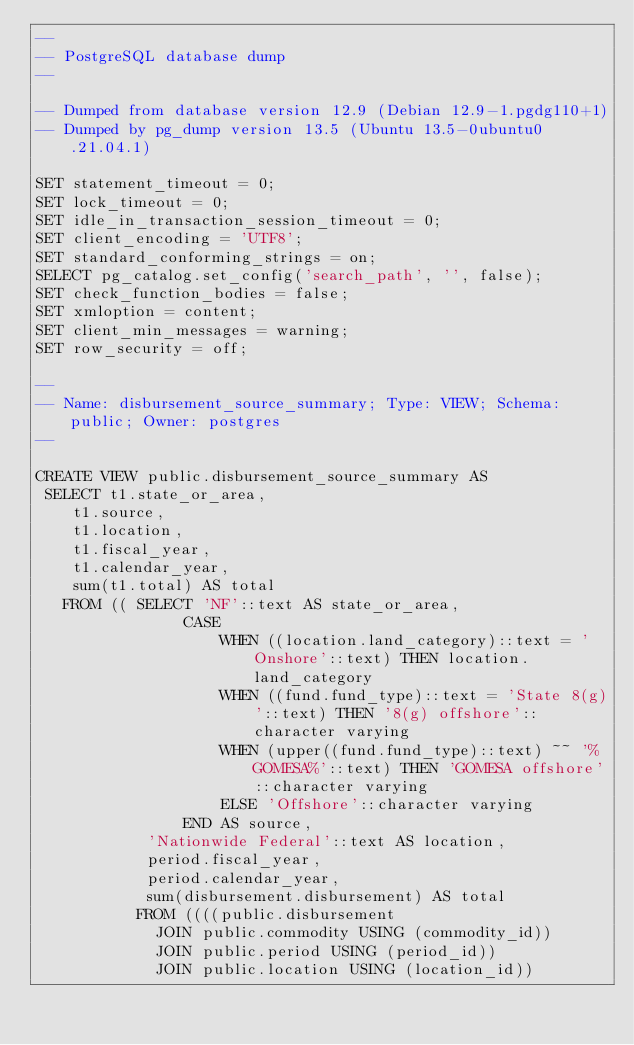Convert code to text. <code><loc_0><loc_0><loc_500><loc_500><_SQL_>--
-- PostgreSQL database dump
--

-- Dumped from database version 12.9 (Debian 12.9-1.pgdg110+1)
-- Dumped by pg_dump version 13.5 (Ubuntu 13.5-0ubuntu0.21.04.1)

SET statement_timeout = 0;
SET lock_timeout = 0;
SET idle_in_transaction_session_timeout = 0;
SET client_encoding = 'UTF8';
SET standard_conforming_strings = on;
SELECT pg_catalog.set_config('search_path', '', false);
SET check_function_bodies = false;
SET xmloption = content;
SET client_min_messages = warning;
SET row_security = off;

--
-- Name: disbursement_source_summary; Type: VIEW; Schema: public; Owner: postgres
--

CREATE VIEW public.disbursement_source_summary AS
 SELECT t1.state_or_area,
    t1.source,
    t1.location,
    t1.fiscal_year,
    t1.calendar_year,
    sum(t1.total) AS total
   FROM (( SELECT 'NF'::text AS state_or_area,
                CASE
                    WHEN ((location.land_category)::text = 'Onshore'::text) THEN location.land_category
                    WHEN ((fund.fund_type)::text = 'State 8(g)'::text) THEN '8(g) offshore'::character varying
                    WHEN (upper((fund.fund_type)::text) ~~ '%GOMESA%'::text) THEN 'GOMESA offshore'::character varying
                    ELSE 'Offshore'::character varying
                END AS source,
            'Nationwide Federal'::text AS location,
            period.fiscal_year,
            period.calendar_year,
            sum(disbursement.disbursement) AS total
           FROM ((((public.disbursement
             JOIN public.commodity USING (commodity_id))
             JOIN public.period USING (period_id))
             JOIN public.location USING (location_id))</code> 